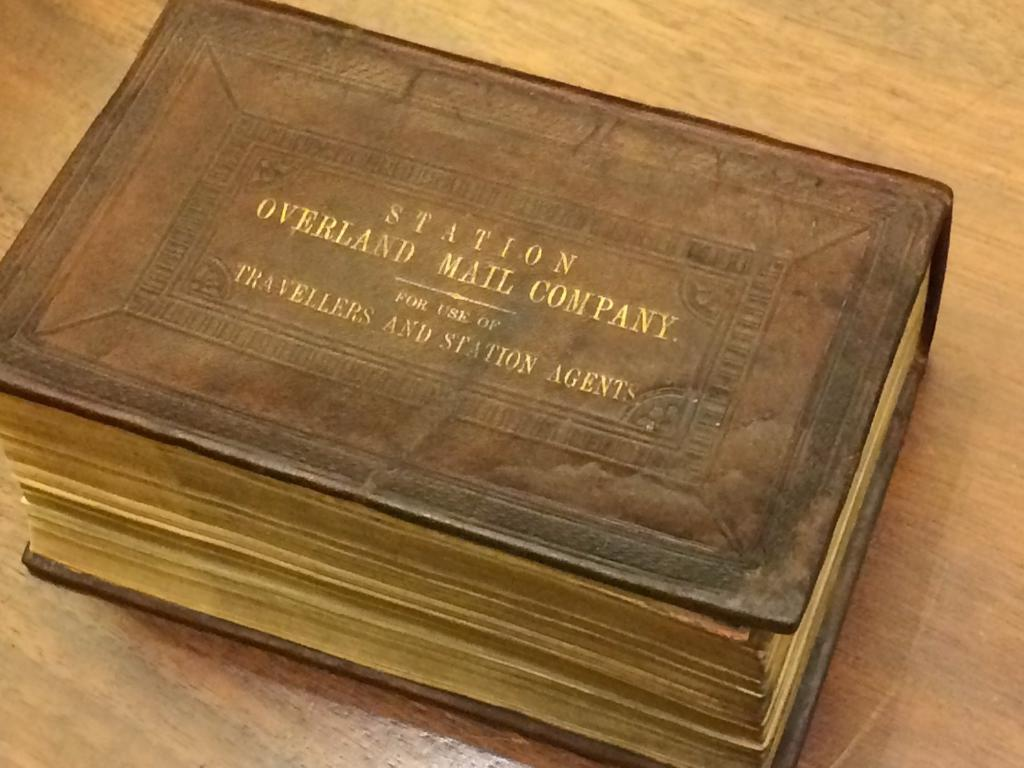<image>
Summarize the visual content of the image. An old book with gold writing that says Station overland Mail company. 